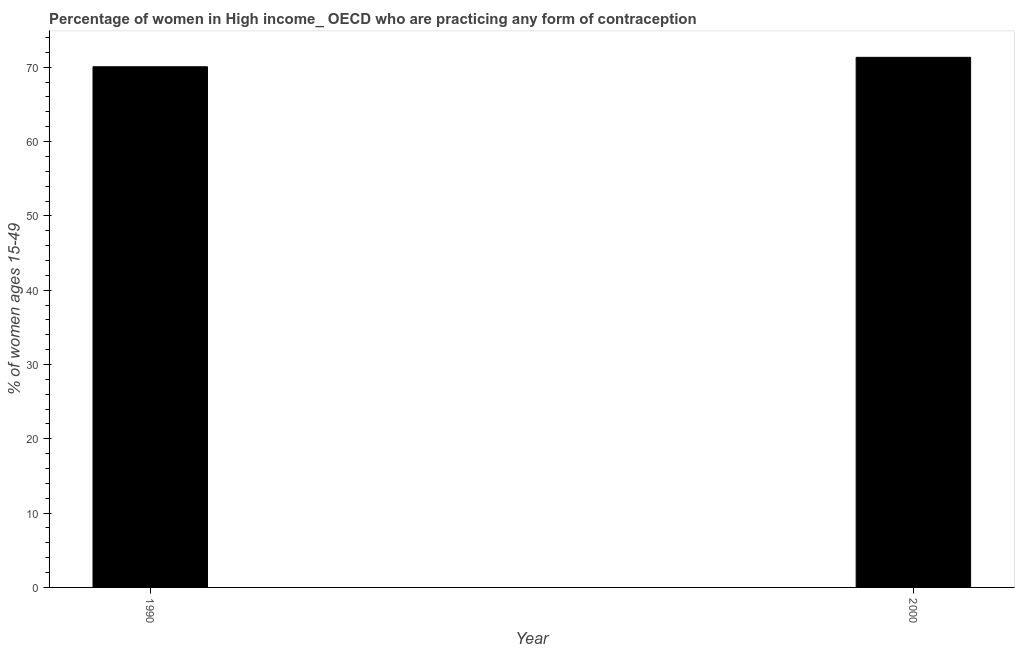Does the graph contain grids?
Your response must be concise. No. What is the title of the graph?
Provide a succinct answer. Percentage of women in High income_ OECD who are practicing any form of contraception. What is the label or title of the X-axis?
Provide a succinct answer. Year. What is the label or title of the Y-axis?
Ensure brevity in your answer.  % of women ages 15-49. What is the contraceptive prevalence in 2000?
Keep it short and to the point. 71.34. Across all years, what is the maximum contraceptive prevalence?
Offer a very short reply. 71.34. Across all years, what is the minimum contraceptive prevalence?
Keep it short and to the point. 70.07. What is the sum of the contraceptive prevalence?
Provide a short and direct response. 141.4. What is the difference between the contraceptive prevalence in 1990 and 2000?
Provide a short and direct response. -1.27. What is the average contraceptive prevalence per year?
Give a very brief answer. 70.7. What is the median contraceptive prevalence?
Give a very brief answer. 70.7. In how many years, is the contraceptive prevalence greater than 68 %?
Your answer should be compact. 2. In how many years, is the contraceptive prevalence greater than the average contraceptive prevalence taken over all years?
Provide a succinct answer. 1. Are the values on the major ticks of Y-axis written in scientific E-notation?
Your answer should be very brief. No. What is the % of women ages 15-49 in 1990?
Keep it short and to the point. 70.07. What is the % of women ages 15-49 of 2000?
Keep it short and to the point. 71.34. What is the difference between the % of women ages 15-49 in 1990 and 2000?
Your response must be concise. -1.27. What is the ratio of the % of women ages 15-49 in 1990 to that in 2000?
Your answer should be compact. 0.98. 